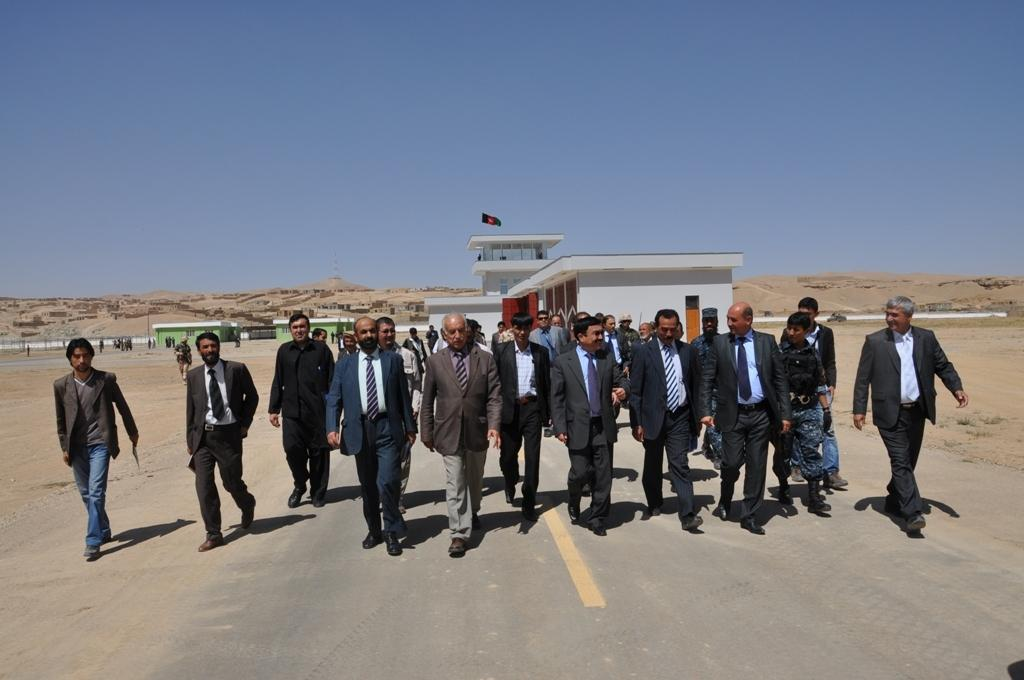What are the people in the image wearing? The people in the image are wearing suits. What are the people with suits doing in the image? The people are walking on the road. What can be seen in the background of the image? There are buildings in the background of the image. What else is present in the image besides the people and buildings? There are poles and a flag in the image. What is visible at the top of the image? The sky is visible at the top of the image. How many tomatoes are hanging from the flag in the image? There are no tomatoes present in the image, and therefore none are hanging from the flag. What historical event is being commemorated by the people in the image? There is no indication of a specific historical event being commemorated in the image. 